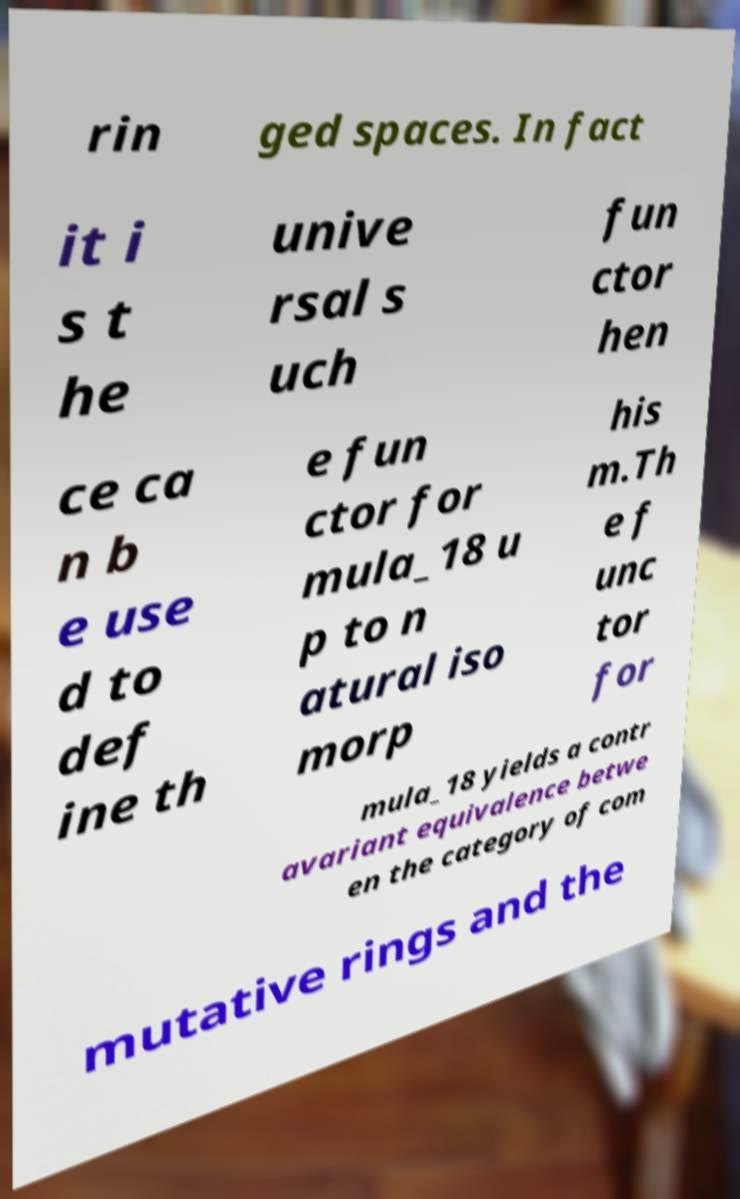I need the written content from this picture converted into text. Can you do that? rin ged spaces. In fact it i s t he unive rsal s uch fun ctor hen ce ca n b e use d to def ine th e fun ctor for mula_18 u p to n atural iso morp his m.Th e f unc tor for mula_18 yields a contr avariant equivalence betwe en the category of com mutative rings and the 